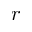Convert formula to latex. <formula><loc_0><loc_0><loc_500><loc_500>r</formula> 